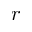Convert formula to latex. <formula><loc_0><loc_0><loc_500><loc_500>r</formula> 